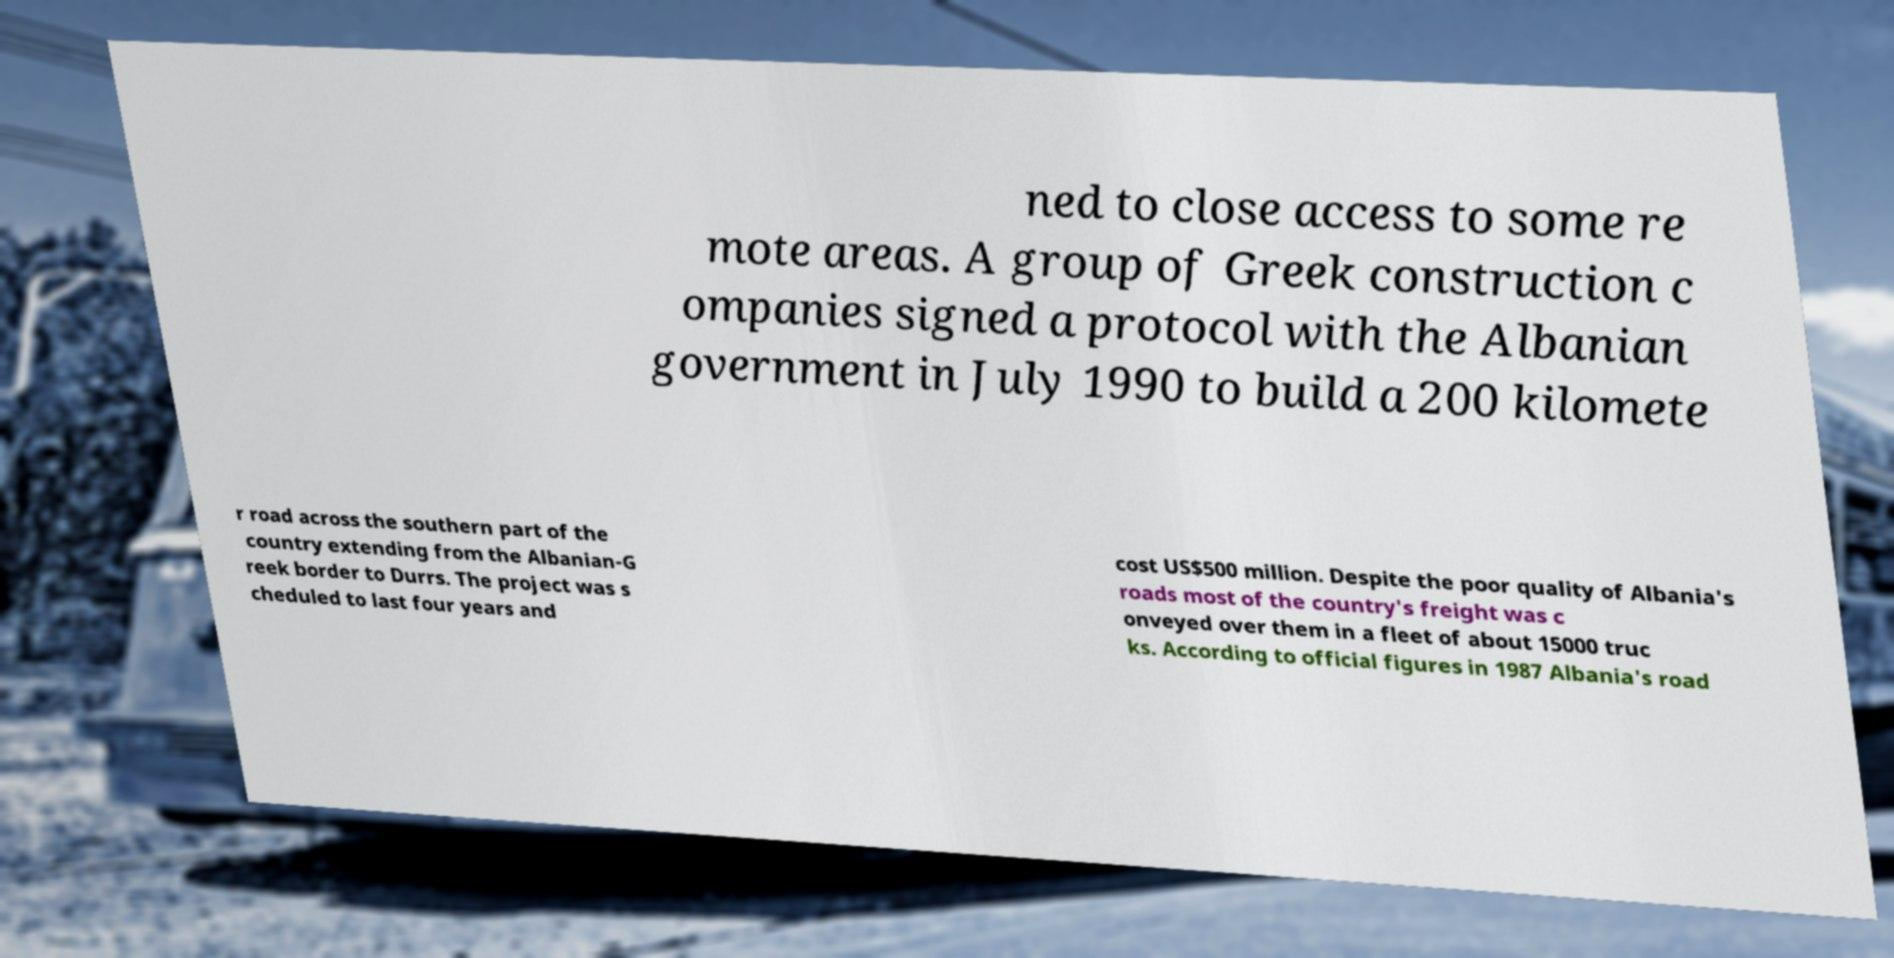Can you accurately transcribe the text from the provided image for me? ned to close access to some re mote areas. A group of Greek construction c ompanies signed a protocol with the Albanian government in July 1990 to build a 200 kilomete r road across the southern part of the country extending from the Albanian-G reek border to Durrs. The project was s cheduled to last four years and cost US$500 million. Despite the poor quality of Albania's roads most of the country's freight was c onveyed over them in a fleet of about 15000 truc ks. According to official figures in 1987 Albania's road 